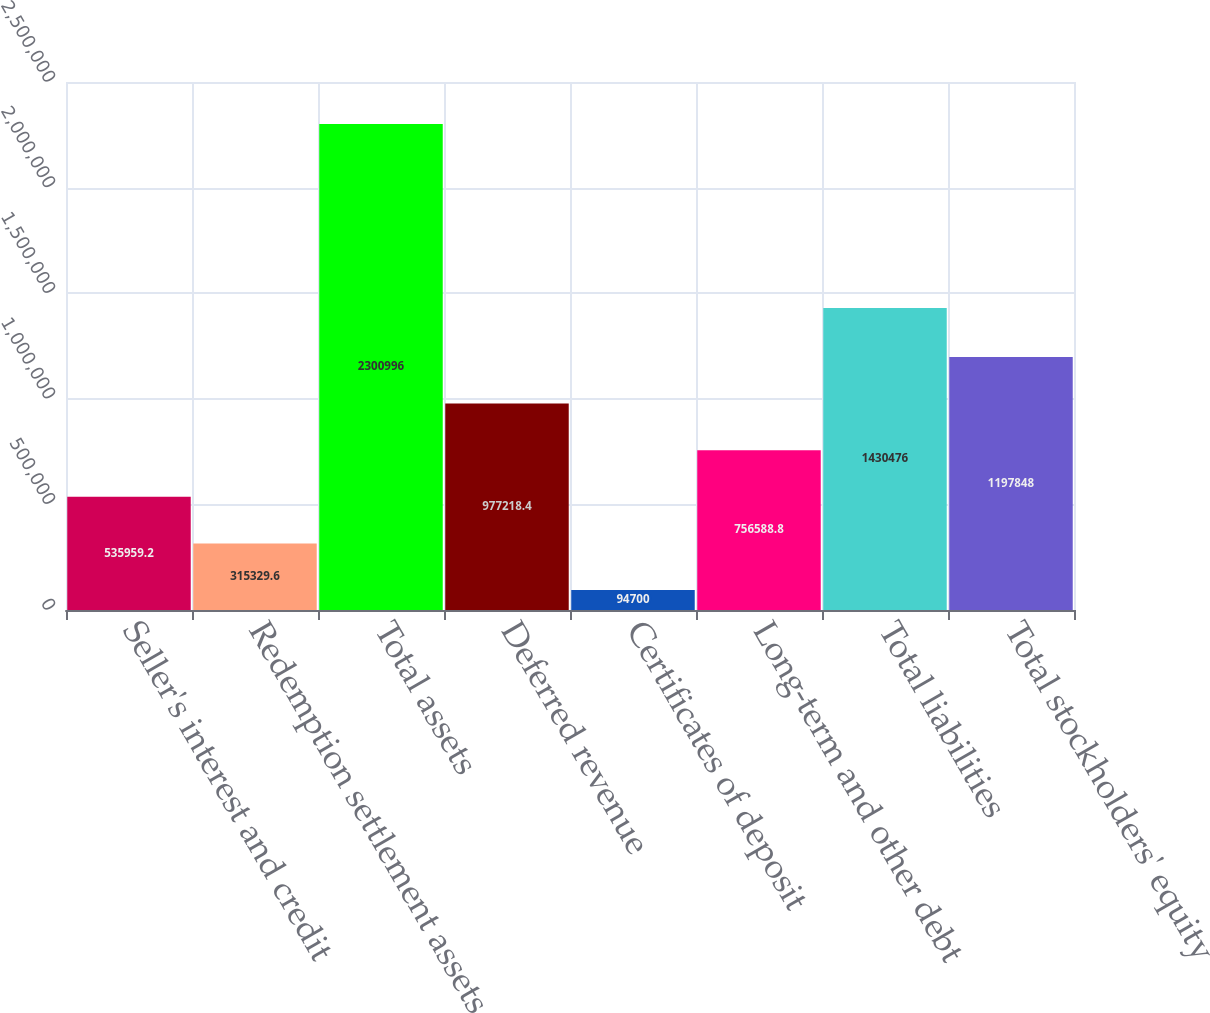<chart> <loc_0><loc_0><loc_500><loc_500><bar_chart><fcel>Seller's interest and credit<fcel>Redemption settlement assets<fcel>Total assets<fcel>Deferred revenue<fcel>Certificates of deposit<fcel>Long-term and other debt<fcel>Total liabilities<fcel>Total stockholders' equity<nl><fcel>535959<fcel>315330<fcel>2.301e+06<fcel>977218<fcel>94700<fcel>756589<fcel>1.43048e+06<fcel>1.19785e+06<nl></chart> 